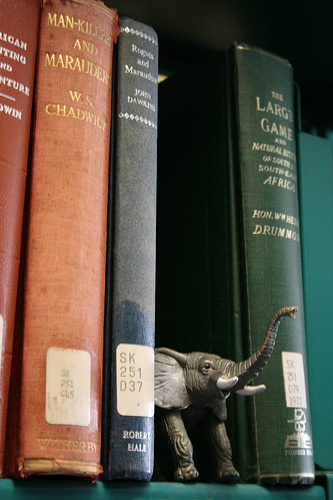<image>
Can you confirm if the elephant is behind the book? No. The elephant is not behind the book. From this viewpoint, the elephant appears to be positioned elsewhere in the scene. Where is the elephant in relation to the book? Is it in front of the book? Yes. The elephant is positioned in front of the book, appearing closer to the camera viewpoint. 